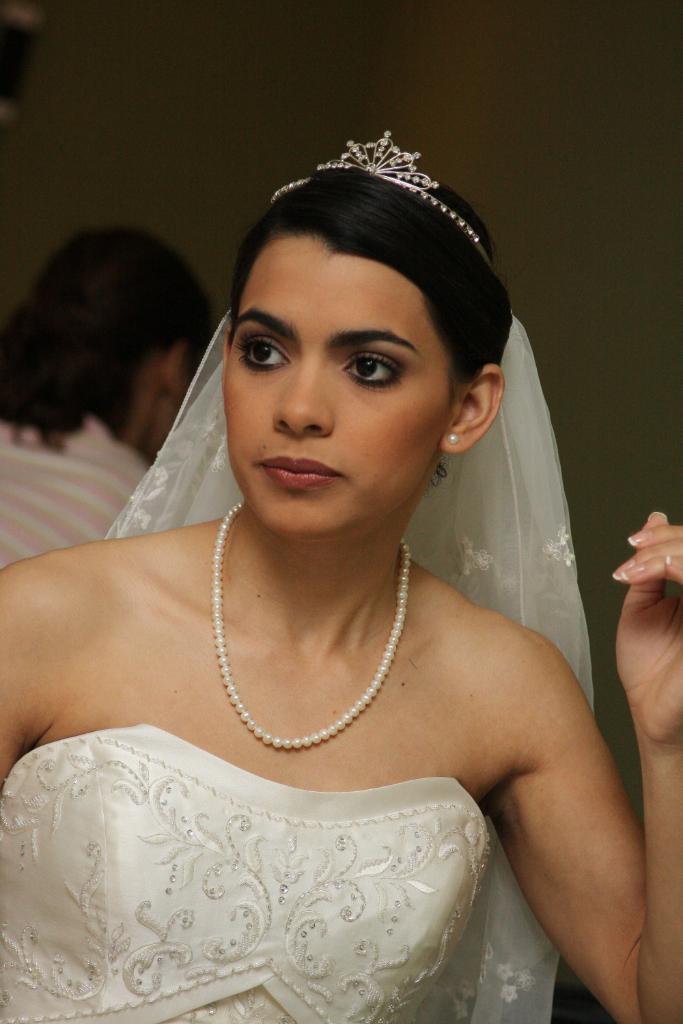Please provide a concise description of this image. In this picture there is a woman in bridal dress, behind her there is a person sitting. The background is blurred. 